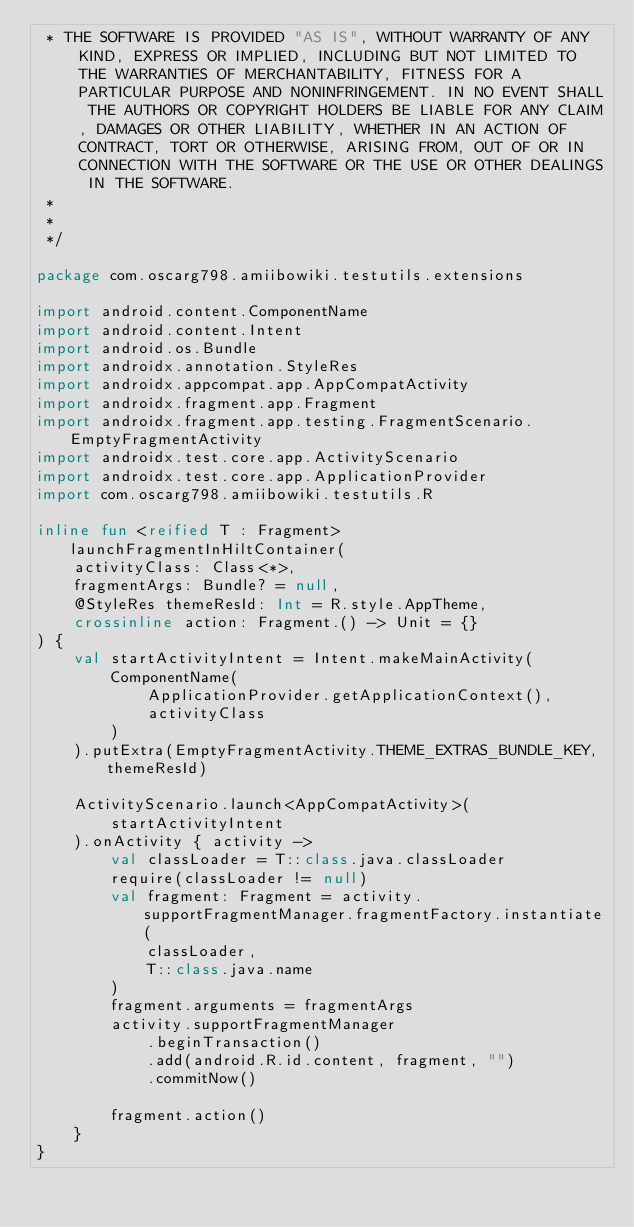<code> <loc_0><loc_0><loc_500><loc_500><_Kotlin_> * THE SOFTWARE IS PROVIDED "AS IS", WITHOUT WARRANTY OF ANY KIND, EXPRESS OR IMPLIED, INCLUDING BUT NOT LIMITED TO THE WARRANTIES OF MERCHANTABILITY, FITNESS FOR A PARTICULAR PURPOSE AND NONINFRINGEMENT. IN NO EVENT SHALL THE AUTHORS OR COPYRIGHT HOLDERS BE LIABLE FOR ANY CLAIM, DAMAGES OR OTHER LIABILITY, WHETHER IN AN ACTION OF CONTRACT, TORT OR OTHERWISE, ARISING FROM, OUT OF OR IN CONNECTION WITH THE SOFTWARE OR THE USE OR OTHER DEALINGS IN THE SOFTWARE.
 *
 *
 */

package com.oscarg798.amiibowiki.testutils.extensions

import android.content.ComponentName
import android.content.Intent
import android.os.Bundle
import androidx.annotation.StyleRes
import androidx.appcompat.app.AppCompatActivity
import androidx.fragment.app.Fragment
import androidx.fragment.app.testing.FragmentScenario.EmptyFragmentActivity
import androidx.test.core.app.ActivityScenario
import androidx.test.core.app.ApplicationProvider
import com.oscarg798.amiibowiki.testutils.R

inline fun <reified T : Fragment> launchFragmentInHiltContainer(
    activityClass: Class<*>,
    fragmentArgs: Bundle? = null,
    @StyleRes themeResId: Int = R.style.AppTheme,
    crossinline action: Fragment.() -> Unit = {}
) {
    val startActivityIntent = Intent.makeMainActivity(
        ComponentName(
            ApplicationProvider.getApplicationContext(),
            activityClass
        )
    ).putExtra(EmptyFragmentActivity.THEME_EXTRAS_BUNDLE_KEY, themeResId)

    ActivityScenario.launch<AppCompatActivity>(
        startActivityIntent
    ).onActivity { activity ->
        val classLoader = T::class.java.classLoader
        require(classLoader != null)
        val fragment: Fragment = activity.supportFragmentManager.fragmentFactory.instantiate(
            classLoader,
            T::class.java.name
        )
        fragment.arguments = fragmentArgs
        activity.supportFragmentManager
            .beginTransaction()
            .add(android.R.id.content, fragment, "")
            .commitNow()

        fragment.action()
    }
}
</code> 